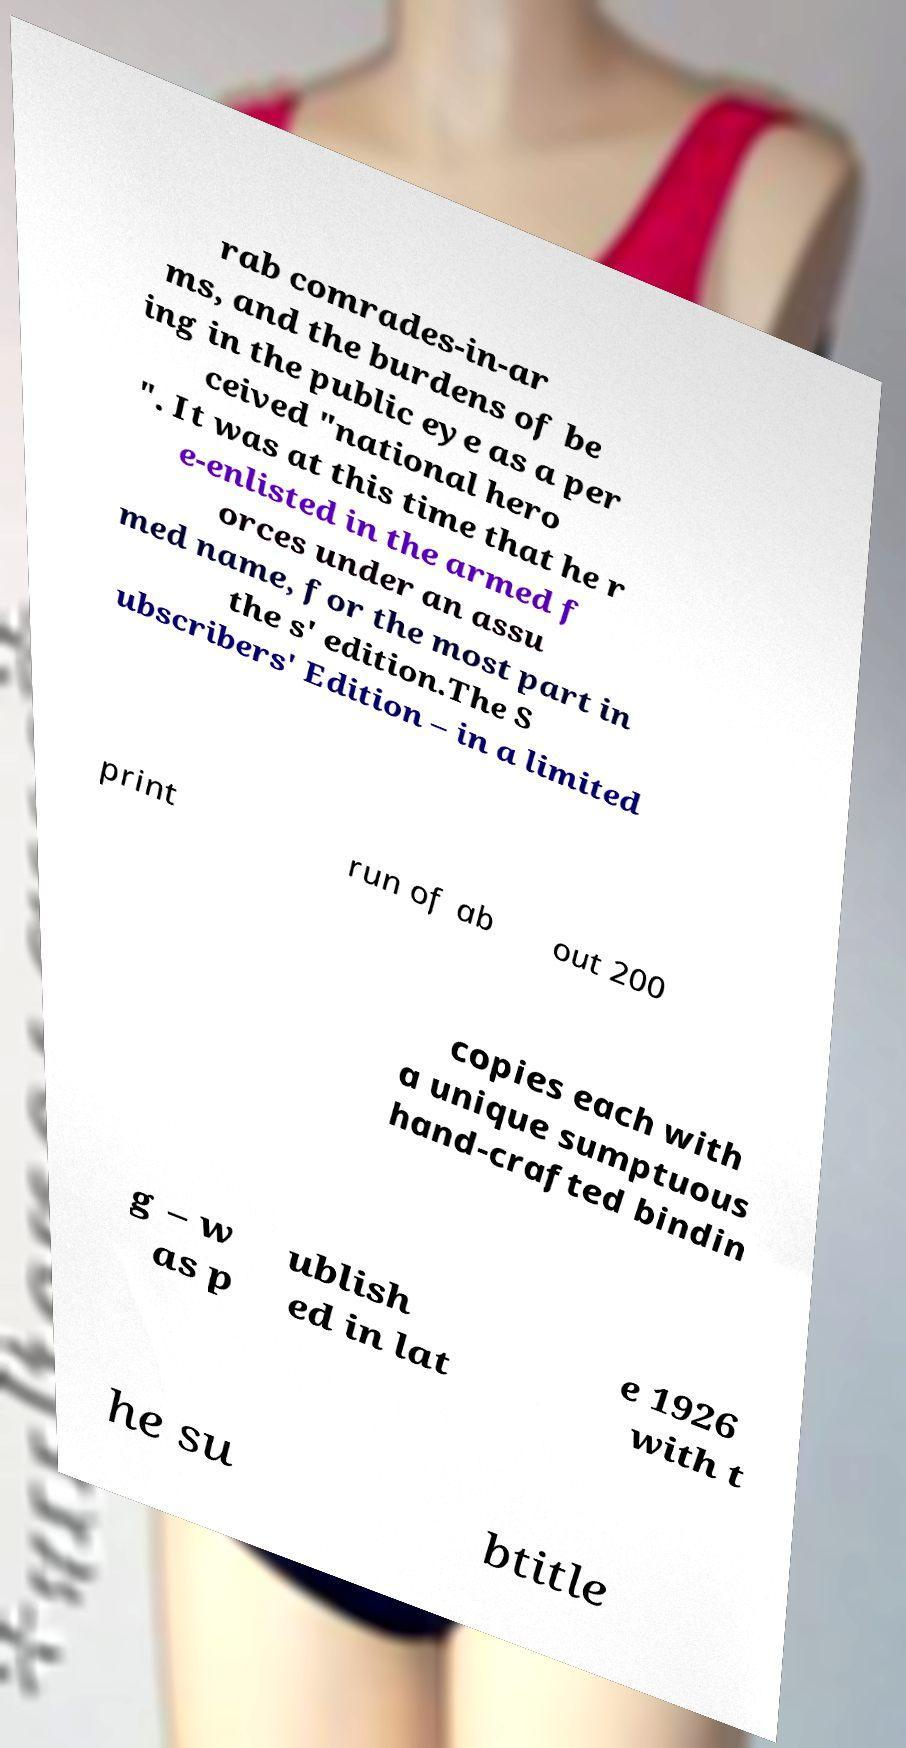Can you read and provide the text displayed in the image?This photo seems to have some interesting text. Can you extract and type it out for me? rab comrades-in-ar ms, and the burdens of be ing in the public eye as a per ceived "national hero ". It was at this time that he r e-enlisted in the armed f orces under an assu med name, for the most part in the s' edition.The S ubscribers' Edition – in a limited print run of ab out 200 copies each with a unique sumptuous hand-crafted bindin g – w as p ublish ed in lat e 1926 with t he su btitle 